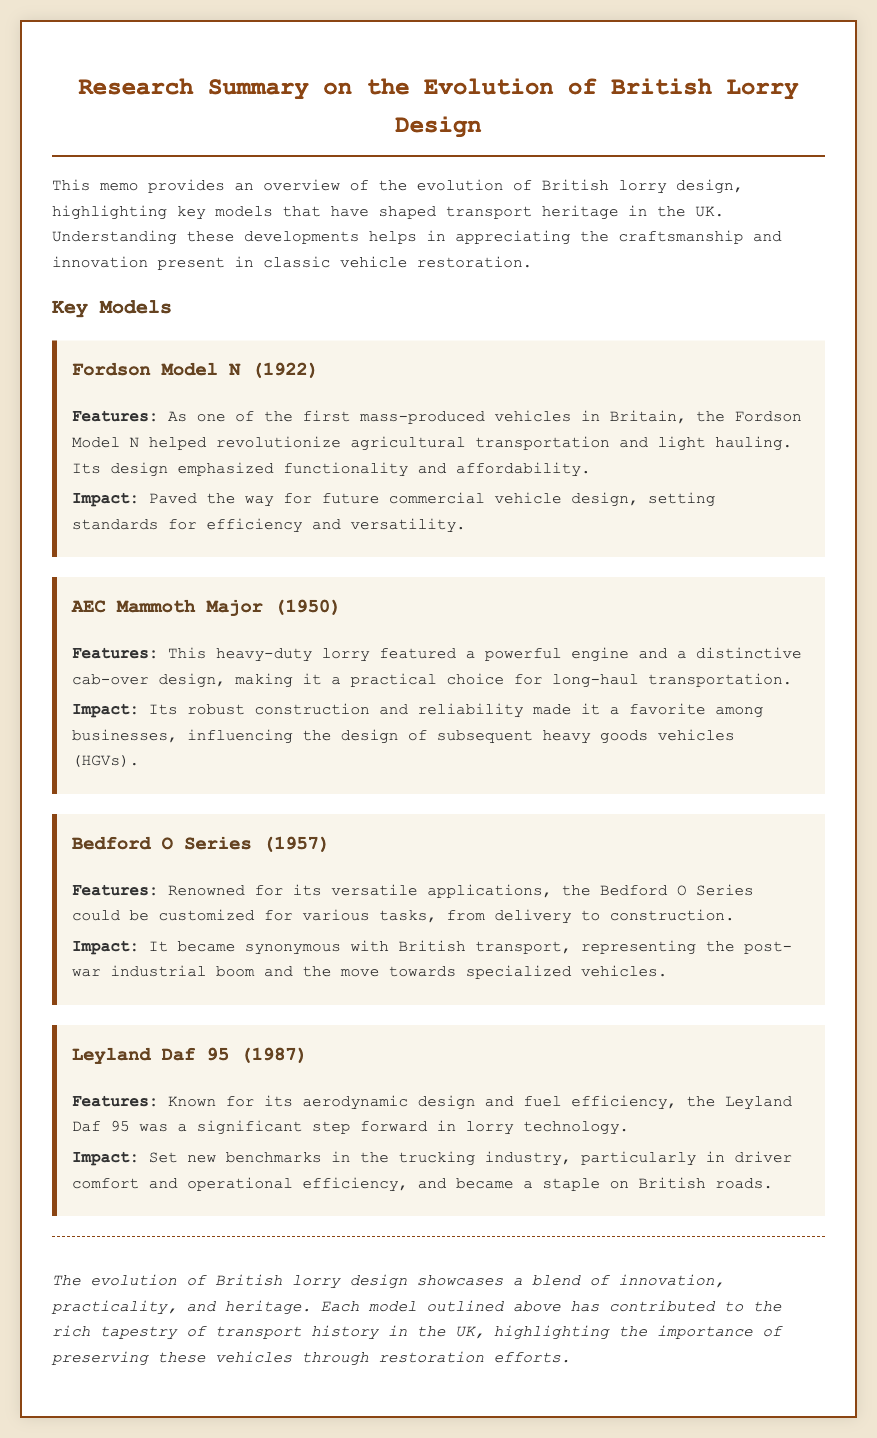What year was the Fordson Model N released? The Fordson Model N was released in 1922, as stated in the key models section of the memo.
Answer: 1922 What is a unique feature of the AEC Mammoth Major? The AEC Mammoth Major is noted for its distinctive cab-over design, which is mentioned among its features.
Answer: Cab-over design What does the Bedford O Series represent in British transport? The Bedford O Series symbolizes the post-war industrial boom and the shift towards specialized vehicles, as highlighted in its impact section.
Answer: Post-war industrial boom In what year was the Leyland Daf 95 introduced? The Leyland Daf 95 was introduced in 1987, as indicated in the key models section.
Answer: 1987 Which model emphasized functionality and affordability? The Fordson Model N is specifically highlighted for its focus on functionality and affordability in the memo.
Answer: Fordson Model N What major aspect of the Leyland Daf 95 was improved? The Leyland Daf 95 is recognized for setting new benchmarks in driver comfort and operational efficiency.
Answer: Driver comfort and operational efficiency What type of vehicle was the Bedford O Series primarily used for? The Bedford O Series could be customized for various tasks, including delivery and construction, according to its features.
Answer: Delivery and construction What does the conclusion of the memo highlight? The conclusion highlights the blend of innovation, practicality, and heritage in the evolution of British lorry design.
Answer: Innovation, practicality, and heritage 